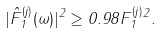Convert formula to latex. <formula><loc_0><loc_0><loc_500><loc_500>| \hat { F } _ { 1 } ^ { ( j ) } ( \omega ) | ^ { 2 } \geq 0 . 9 8 \| F _ { 1 } ^ { ( j ) } \| ^ { 2 } .</formula> 